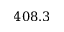Convert formula to latex. <formula><loc_0><loc_0><loc_500><loc_500>4 0 8 . 3</formula> 